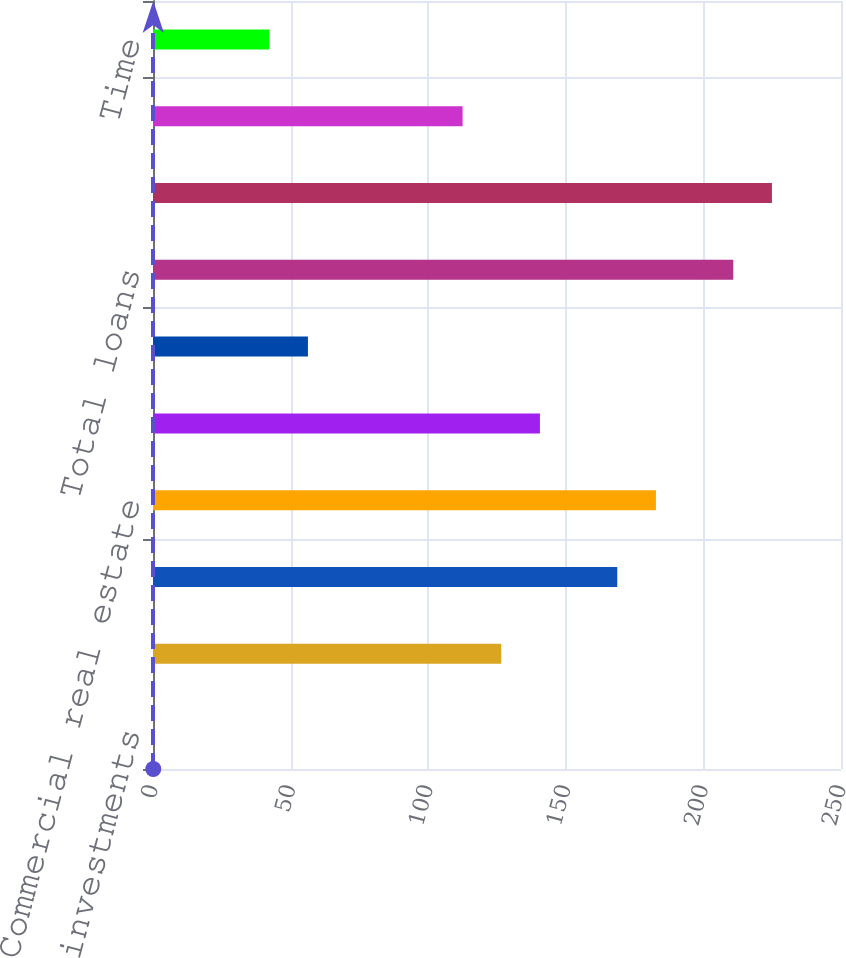Convert chart to OTSL. <chart><loc_0><loc_0><loc_500><loc_500><bar_chart><fcel>Short-term investments<fcel>Securities<fcel>Commercial<fcel>Commercial real estate<fcel>Residential mortgage<fcel>Consumer<fcel>Total loans<fcel>Total change in interest and<fcel>Savings interest-bearing<fcel>Time<nl><fcel>0.1<fcel>126.55<fcel>168.7<fcel>182.75<fcel>140.6<fcel>56.3<fcel>210.85<fcel>224.9<fcel>112.5<fcel>42.25<nl></chart> 